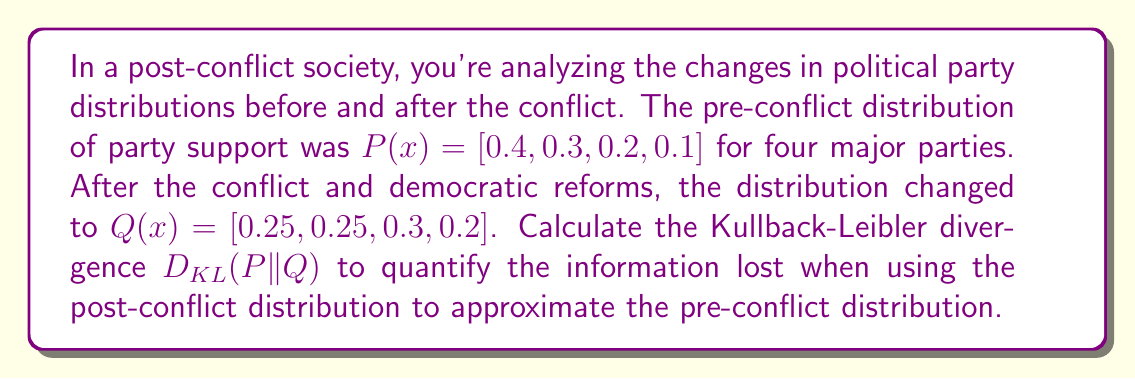Can you solve this math problem? To solve this problem, we'll use the Kullback-Leibler divergence formula:

$$D_{KL}(P||Q) = \sum_{i} P(i) \log\left(\frac{P(i)}{Q(i)}\right)$$

Where P(i) is the probability of the i-th event in the pre-conflict distribution, and Q(i) is the probability of the i-th event in the post-conflict distribution.

Let's calculate each term of the sum:

1. For i = 1:
   $$0.4 \log\left(\frac{0.4}{0.25}\right) = 0.4 \log(1.6) \approx 0.1438$$

2. For i = 2:
   $$0.3 \log\left(\frac{0.3}{0.25}\right) = 0.3 \log(1.2) \approx 0.0547$$

3. For i = 3:
   $$0.2 \log\left(\frac{0.2}{0.3}\right) = 0.2 \log(0.6667) \approx -0.0811$$

4. For i = 4:
   $$0.1 \log\left(\frac{0.1}{0.2}\right) = 0.1 \log(0.5) \approx -0.0693$$

Now, we sum all these terms:

$$D_{KL}(P||Q) = 0.1438 + 0.0547 - 0.0811 - 0.0693 \approx 0.0481$$

This positive value indicates that some information is lost when using the post-conflict distribution to approximate the pre-conflict distribution, which is expected given the changes in political party support after the conflict.
Answer: The Kullback-Leibler divergence D_KL(P||Q) ≈ 0.0481 